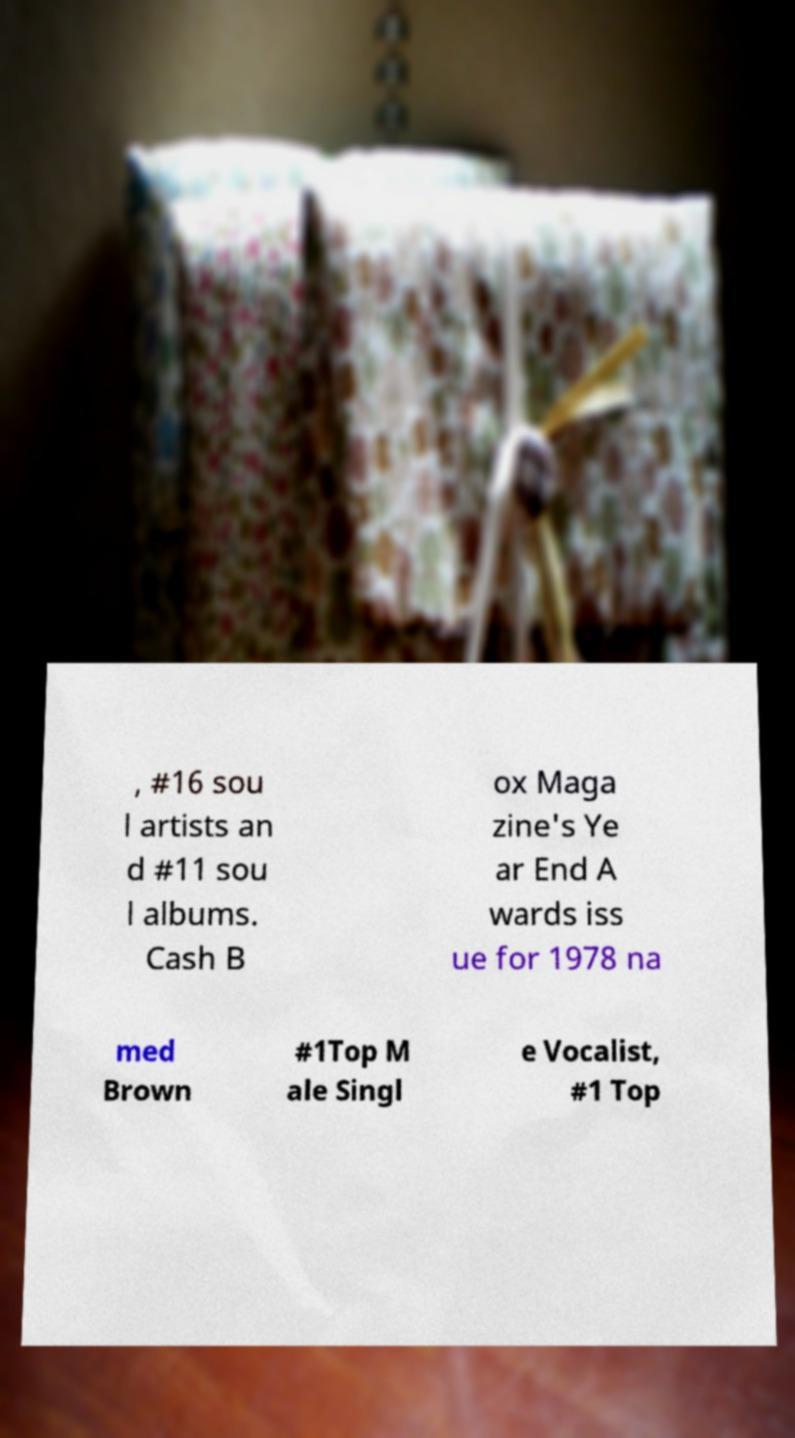Please read and relay the text visible in this image. What does it say? , #16 sou l artists an d #11 sou l albums. Cash B ox Maga zine's Ye ar End A wards iss ue for 1978 na med Brown #1Top M ale Singl e Vocalist, #1 Top 